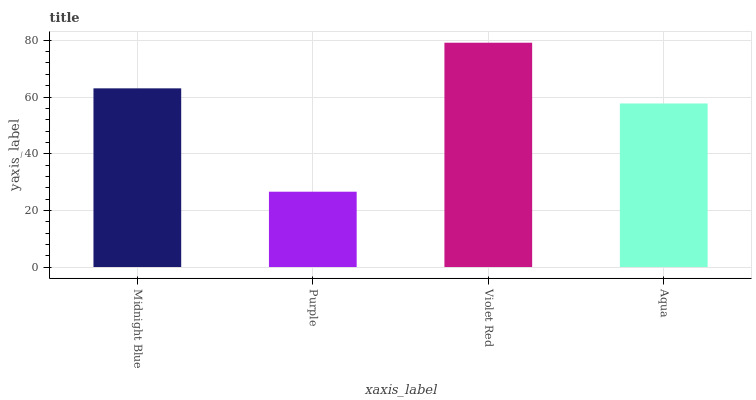Is Purple the minimum?
Answer yes or no. Yes. Is Violet Red the maximum?
Answer yes or no. Yes. Is Violet Red the minimum?
Answer yes or no. No. Is Purple the maximum?
Answer yes or no. No. Is Violet Red greater than Purple?
Answer yes or no. Yes. Is Purple less than Violet Red?
Answer yes or no. Yes. Is Purple greater than Violet Red?
Answer yes or no. No. Is Violet Red less than Purple?
Answer yes or no. No. Is Midnight Blue the high median?
Answer yes or no. Yes. Is Aqua the low median?
Answer yes or no. Yes. Is Purple the high median?
Answer yes or no. No. Is Midnight Blue the low median?
Answer yes or no. No. 